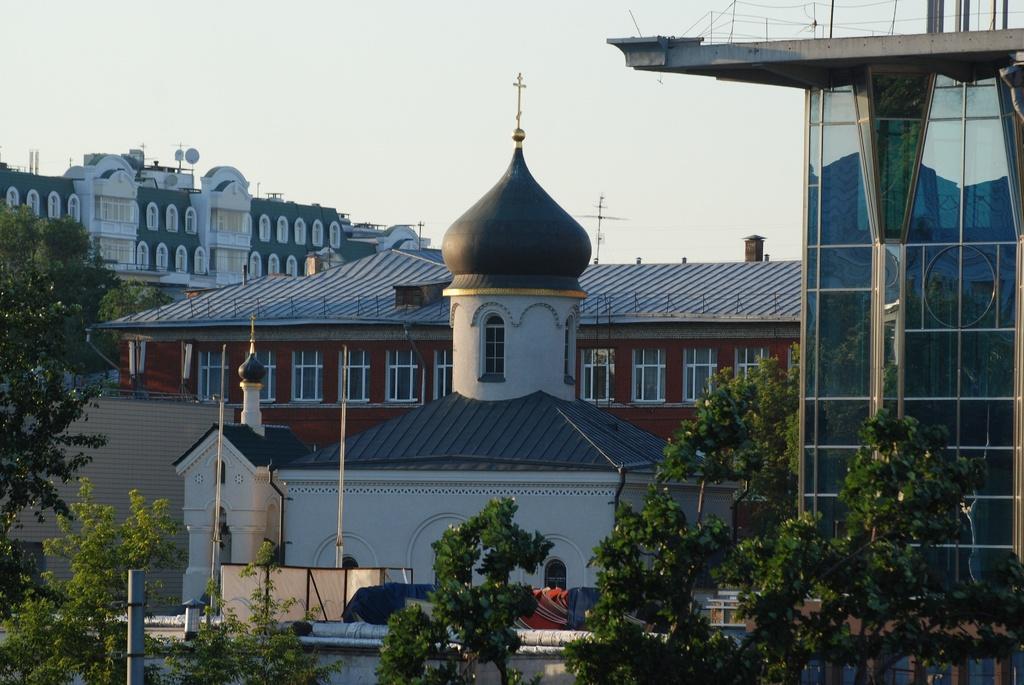How would you summarize this image in a sentence or two? In this image in the foreground there are trees. In the background there are buildings. The sky is clear. On top of this building there is cross mark. 